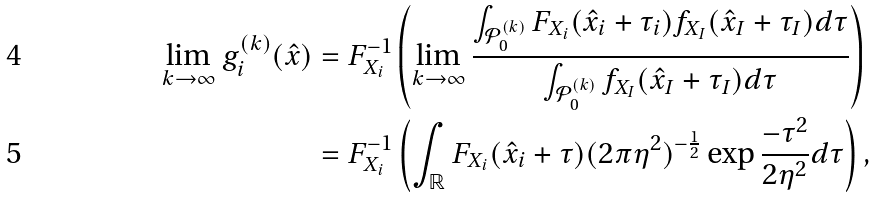Convert formula to latex. <formula><loc_0><loc_0><loc_500><loc_500>\lim _ { k \rightarrow \infty } g _ { i } ^ { ( k ) } ( \hat { x } ) & = F _ { X _ { i } } ^ { - 1 } \left ( \lim _ { k \rightarrow \infty } \frac { \int _ { \mathcal { P } _ { 0 } ^ { ( k ) } } F _ { X _ { i } } ( \hat { x } _ { i } + \tau _ { i } ) f _ { X _ { I } } ( \hat { x } _ { I } + \tau _ { I } ) d \tau } { \int _ { \mathcal { P } _ { 0 } ^ { ( k ) } } f _ { X _ { I } } ( \hat { x } _ { I } + \tau _ { I } ) d \tau } \right ) \\ & = F _ { X _ { i } } ^ { - 1 } \left ( \int _ { \mathbb { R } } F _ { X _ { i } } ( \hat { x } _ { i } + \tau ) ( 2 \pi \eta ^ { 2 } ) ^ { - \frac { 1 } { 2 } } \exp \frac { - \tau ^ { 2 } } { 2 \eta ^ { 2 } } d \tau \right ) ,</formula> 